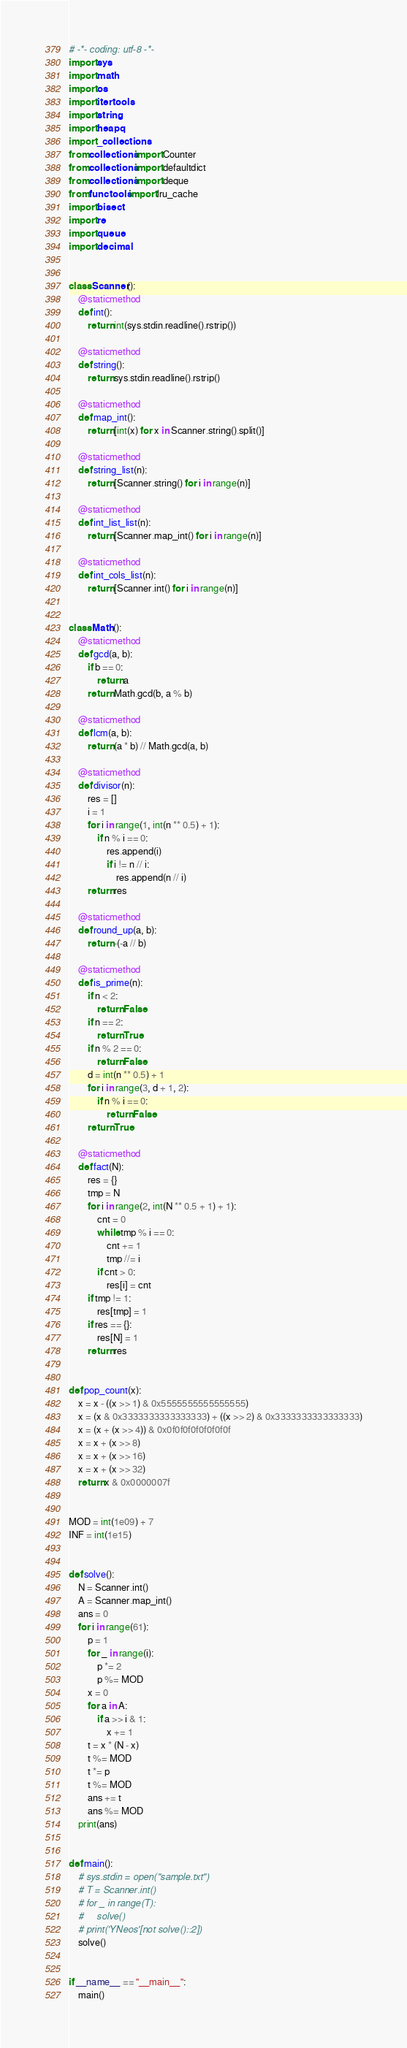<code> <loc_0><loc_0><loc_500><loc_500><_Python_># -*- coding: utf-8 -*-
import sys
import math
import os
import itertools
import string
import heapq
import _collections
from collections import Counter
from collections import defaultdict
from collections import deque
from functools import lru_cache
import bisect
import re
import queue
import decimal


class Scanner():
    @staticmethod
    def int():
        return int(sys.stdin.readline().rstrip())

    @staticmethod
    def string():
        return sys.stdin.readline().rstrip()

    @staticmethod
    def map_int():
        return [int(x) for x in Scanner.string().split()]

    @staticmethod
    def string_list(n):
        return [Scanner.string() for i in range(n)]

    @staticmethod
    def int_list_list(n):
        return [Scanner.map_int() for i in range(n)]

    @staticmethod
    def int_cols_list(n):
        return [Scanner.int() for i in range(n)]


class Math():
    @staticmethod
    def gcd(a, b):
        if b == 0:
            return a
        return Math.gcd(b, a % b)

    @staticmethod
    def lcm(a, b):
        return (a * b) // Math.gcd(a, b)

    @staticmethod
    def divisor(n):
        res = []
        i = 1
        for i in range(1, int(n ** 0.5) + 1):
            if n % i == 0:
                res.append(i)
                if i != n // i:
                    res.append(n // i)
        return res

    @staticmethod
    def round_up(a, b):
        return -(-a // b)

    @staticmethod
    def is_prime(n):
        if n < 2:
            return False
        if n == 2:
            return True
        if n % 2 == 0:
            return False
        d = int(n ** 0.5) + 1
        for i in range(3, d + 1, 2):
            if n % i == 0:
                return False
        return True

    @staticmethod
    def fact(N):
        res = {}
        tmp = N
        for i in range(2, int(N ** 0.5 + 1) + 1):
            cnt = 0
            while tmp % i == 0:
                cnt += 1
                tmp //= i
            if cnt > 0:
                res[i] = cnt
        if tmp != 1:
            res[tmp] = 1
        if res == {}:
            res[N] = 1
        return res


def pop_count(x):
    x = x - ((x >> 1) & 0x5555555555555555)
    x = (x & 0x3333333333333333) + ((x >> 2) & 0x3333333333333333)
    x = (x + (x >> 4)) & 0x0f0f0f0f0f0f0f0f
    x = x + (x >> 8)
    x = x + (x >> 16)
    x = x + (x >> 32)
    return x & 0x0000007f


MOD = int(1e09) + 7
INF = int(1e15)


def solve():
    N = Scanner.int()
    A = Scanner.map_int()
    ans = 0
    for i in range(61):
        p = 1
        for _ in range(i):
            p *= 2
            p %= MOD
        x = 0
        for a in A:
            if a >> i & 1:
                x += 1
        t = x * (N - x)
        t %= MOD
        t *= p
        t %= MOD
        ans += t
        ans %= MOD
    print(ans)


def main():
    # sys.stdin = open("sample.txt")
    # T = Scanner.int()
    # for _ in range(T):
    #     solve()
    # print('YNeos'[not solve()::2])
    solve()


if __name__ == "__main__":
    main()
</code> 